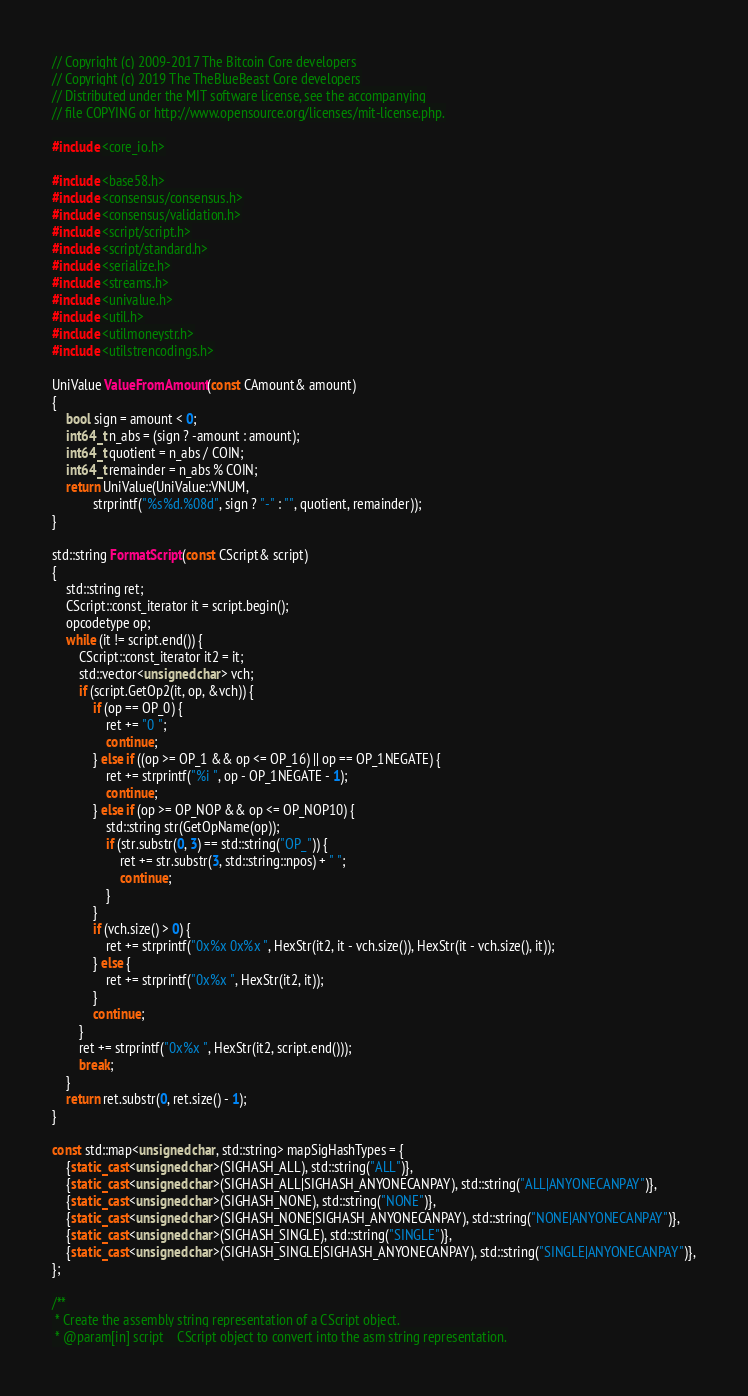Convert code to text. <code><loc_0><loc_0><loc_500><loc_500><_C++_>// Copyright (c) 2009-2017 The Bitcoin Core developers
// Copyright (c) 2019 The TheBlueBeast Core developers
// Distributed under the MIT software license, see the accompanying
// file COPYING or http://www.opensource.org/licenses/mit-license.php.

#include <core_io.h>

#include <base58.h>
#include <consensus/consensus.h>
#include <consensus/validation.h>
#include <script/script.h>
#include <script/standard.h>
#include <serialize.h>
#include <streams.h>
#include <univalue.h>
#include <util.h>
#include <utilmoneystr.h>
#include <utilstrencodings.h>

UniValue ValueFromAmount(const CAmount& amount)
{
    bool sign = amount < 0;
    int64_t n_abs = (sign ? -amount : amount);
    int64_t quotient = n_abs / COIN;
    int64_t remainder = n_abs % COIN;
    return UniValue(UniValue::VNUM,
            strprintf("%s%d.%08d", sign ? "-" : "", quotient, remainder));
}

std::string FormatScript(const CScript& script)
{
    std::string ret;
    CScript::const_iterator it = script.begin();
    opcodetype op;
    while (it != script.end()) {
        CScript::const_iterator it2 = it;
        std::vector<unsigned char> vch;
        if (script.GetOp2(it, op, &vch)) {
            if (op == OP_0) {
                ret += "0 ";
                continue;
            } else if ((op >= OP_1 && op <= OP_16) || op == OP_1NEGATE) {
                ret += strprintf("%i ", op - OP_1NEGATE - 1);
                continue;
            } else if (op >= OP_NOP && op <= OP_NOP10) {
                std::string str(GetOpName(op));
                if (str.substr(0, 3) == std::string("OP_")) {
                    ret += str.substr(3, std::string::npos) + " ";
                    continue;
                }
            }
            if (vch.size() > 0) {
                ret += strprintf("0x%x 0x%x ", HexStr(it2, it - vch.size()), HexStr(it - vch.size(), it));
            } else {
                ret += strprintf("0x%x ", HexStr(it2, it));
            }
            continue;
        }
        ret += strprintf("0x%x ", HexStr(it2, script.end()));
        break;
    }
    return ret.substr(0, ret.size() - 1);
}

const std::map<unsigned char, std::string> mapSigHashTypes = {
    {static_cast<unsigned char>(SIGHASH_ALL), std::string("ALL")},
    {static_cast<unsigned char>(SIGHASH_ALL|SIGHASH_ANYONECANPAY), std::string("ALL|ANYONECANPAY")},
    {static_cast<unsigned char>(SIGHASH_NONE), std::string("NONE")},
    {static_cast<unsigned char>(SIGHASH_NONE|SIGHASH_ANYONECANPAY), std::string("NONE|ANYONECANPAY")},
    {static_cast<unsigned char>(SIGHASH_SINGLE), std::string("SINGLE")},
    {static_cast<unsigned char>(SIGHASH_SINGLE|SIGHASH_ANYONECANPAY), std::string("SINGLE|ANYONECANPAY")},
};

/**
 * Create the assembly string representation of a CScript object.
 * @param[in] script    CScript object to convert into the asm string representation.</code> 